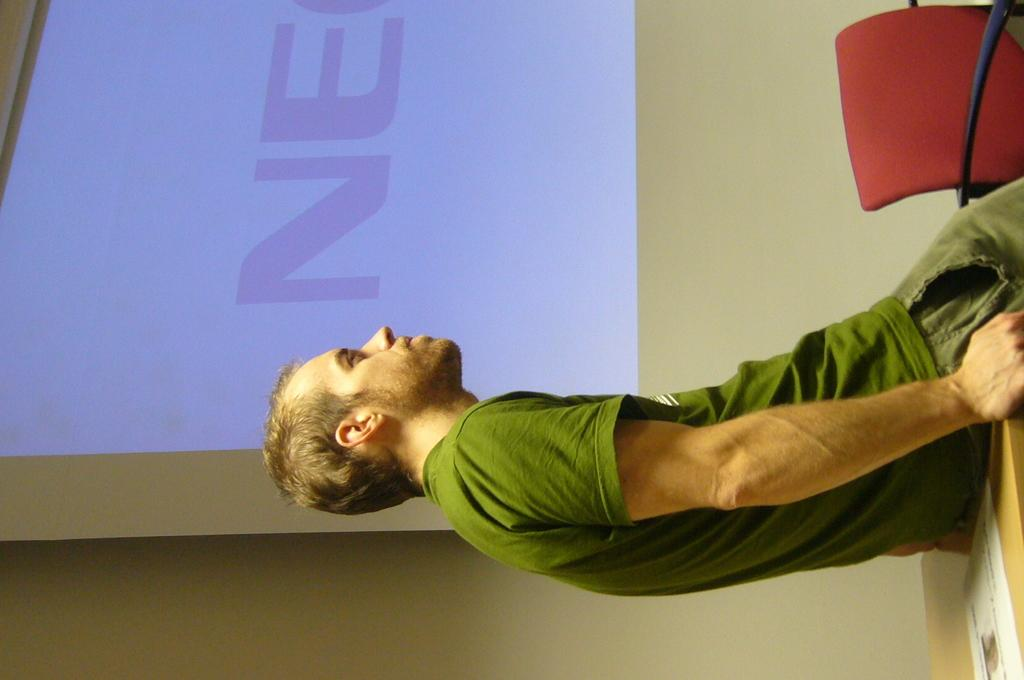What is the man in the image doing? The man is sitting in the image. On what is the man sitting? The man is sitting on a wooden table. Is there any furniture visible in the image? Yes, there is a chair in the image. What can be seen on the wall in the image? There is a projector screen on the wall. What type of bells can be heard ringing in the image? There are no bells present in the image, and therefore no sounds can be heard. 